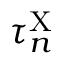<formula> <loc_0><loc_0><loc_500><loc_500>\tau _ { n } ^ { X }</formula> 